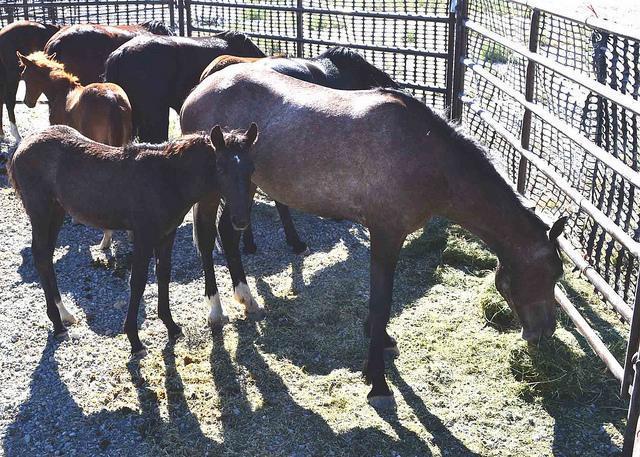How many horses are in the photo?
Give a very brief answer. 7. 